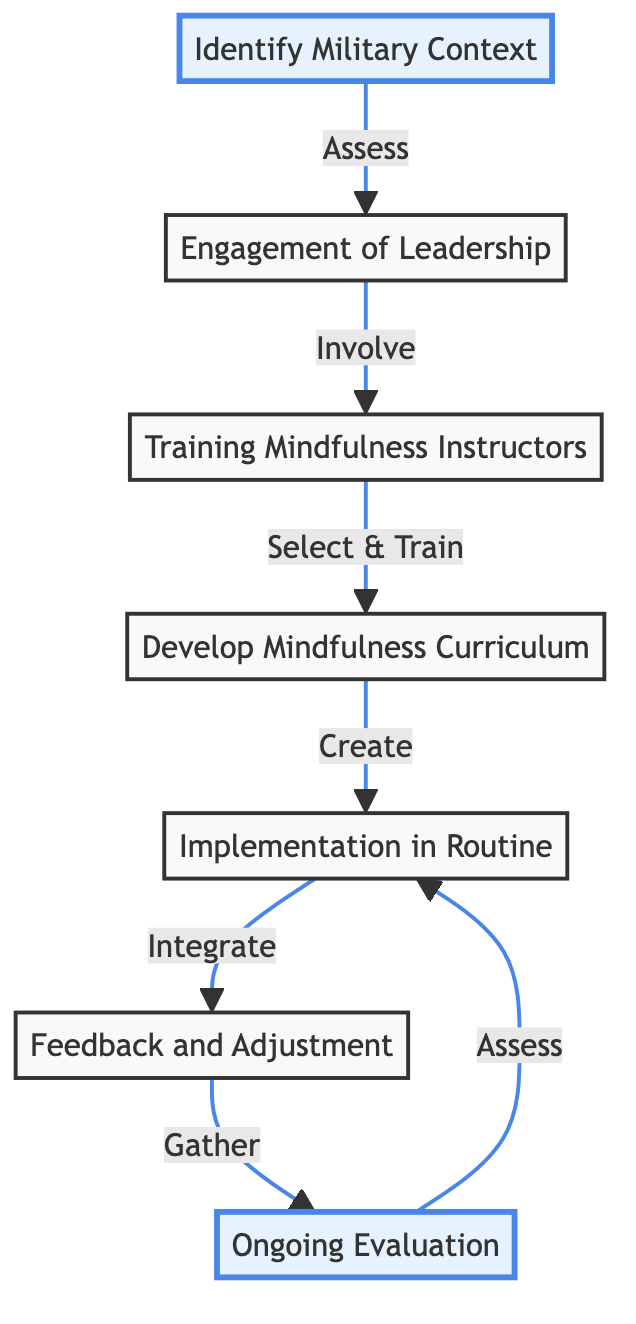What is the first step in the flowchart? The first step in the flowchart is labeled "Identify Military Context," which is depicted as the top node.
Answer: Identify Military Context How many main steps are there in the diagram? There are a total of seven main steps or nodes in the flowchart, as indicated by the numbered elements.
Answer: 7 What is the relationship between "Engagement of Leadership" and "Training Mindfulness Instructors"? "Engagement of Leadership" directly leads to "Training Mindfulness Instructors," indicating that the former is a prerequisite for the latter.
Answer: Involve What does the term "Feedback and Adjustment" indicate in the diagram? "Feedback and Adjustment" represents the process of gathering feedback to evaluate the effectiveness of the program, linking it to the implementation step.
Answer: Gather Which step involves ongoing assessments of mindfulness impact? The step indicated for ongoing assessments is "Ongoing Evaluation," which is positioned at the end of the diagram flow.
Answer: Ongoing Evaluation What type of training is depicted in the third step? The third step describes "Training Mindfulness Instructors," which indicates the selection and preparation of instructors.
Answer: Training Mindfulness Instructors What action is taken after the implementation of mindfulness practices? After the implementation, the next action is "Feedback and Adjustment," which suggests evaluating and refining the mindfulness approach based on participants' feedback.
Answer: Feedback and Adjustment Which two steps are highlighted in the flowchart? The two highlighted steps are "Identify Military Context" and "Ongoing Evaluation," indicating their importance in the flow.
Answer: Identify Military Context and Ongoing Evaluation What does the arrow indicate from "Feedback and Adjustment" to "Ongoing Evaluation"? The arrow signifies that feedback gathered leads to ongoing evaluations for assessing mindfulness practices' impact.
Answer: Assess 